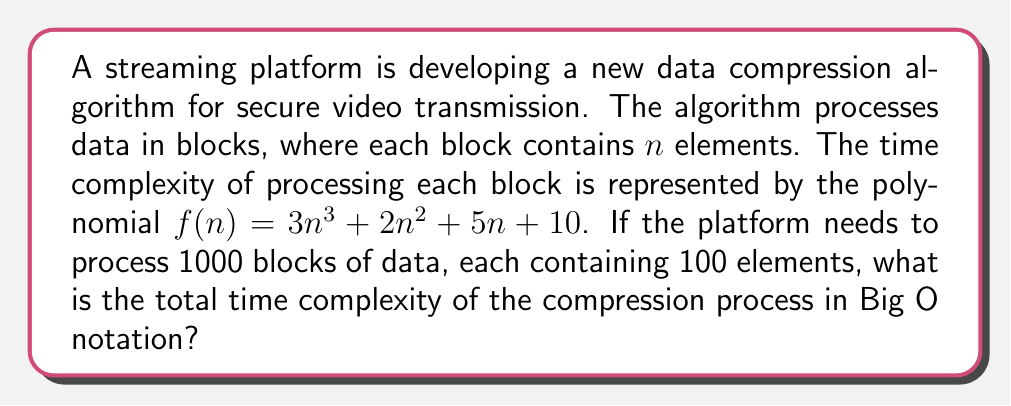Can you answer this question? To solve this problem, we need to follow these steps:

1. Evaluate the time complexity for a single block:
   $f(n) = 3n^3 + 2n^2 + 5n + 10$
   
2. Determine the dominant term in the polynomial:
   The highest degree term is $3n^3$, which dominates as $n$ grows large.
   
3. Express the complexity of a single block in Big O notation:
   $O(n^3)$
   
4. Calculate the total complexity for all blocks:
   - Number of blocks = 1000
   - Elements per block = 100
   - Total complexity = 1000 * $O(100^3)$ = $O(10^8)$

5. Simplify the final expression:
   $O(10^8)$ is a constant, so we can express it as $O(1)$

The total time complexity remains $O(n^3)$ in terms of the input size $n$, as the number of blocks and elements per block are constants in this case.

For cybersecurity concerns, it's important to note that while this analysis focuses on time complexity, a comprehensive security assessment would also consider space complexity and potential vulnerabilities in the compression algorithm that could compromise data integrity or confidentiality.
Answer: $O(n^3)$ 